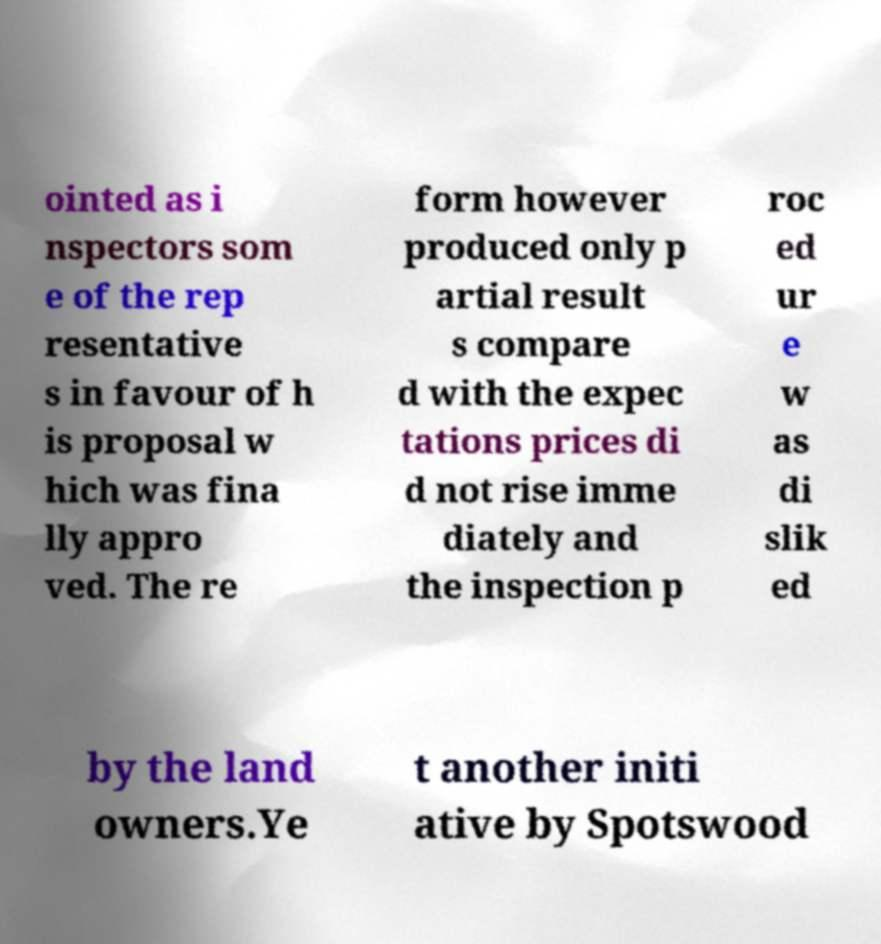Could you assist in decoding the text presented in this image and type it out clearly? ointed as i nspectors som e of the rep resentative s in favour of h is proposal w hich was fina lly appro ved. The re form however produced only p artial result s compare d with the expec tations prices di d not rise imme diately and the inspection p roc ed ur e w as di slik ed by the land owners.Ye t another initi ative by Spotswood 